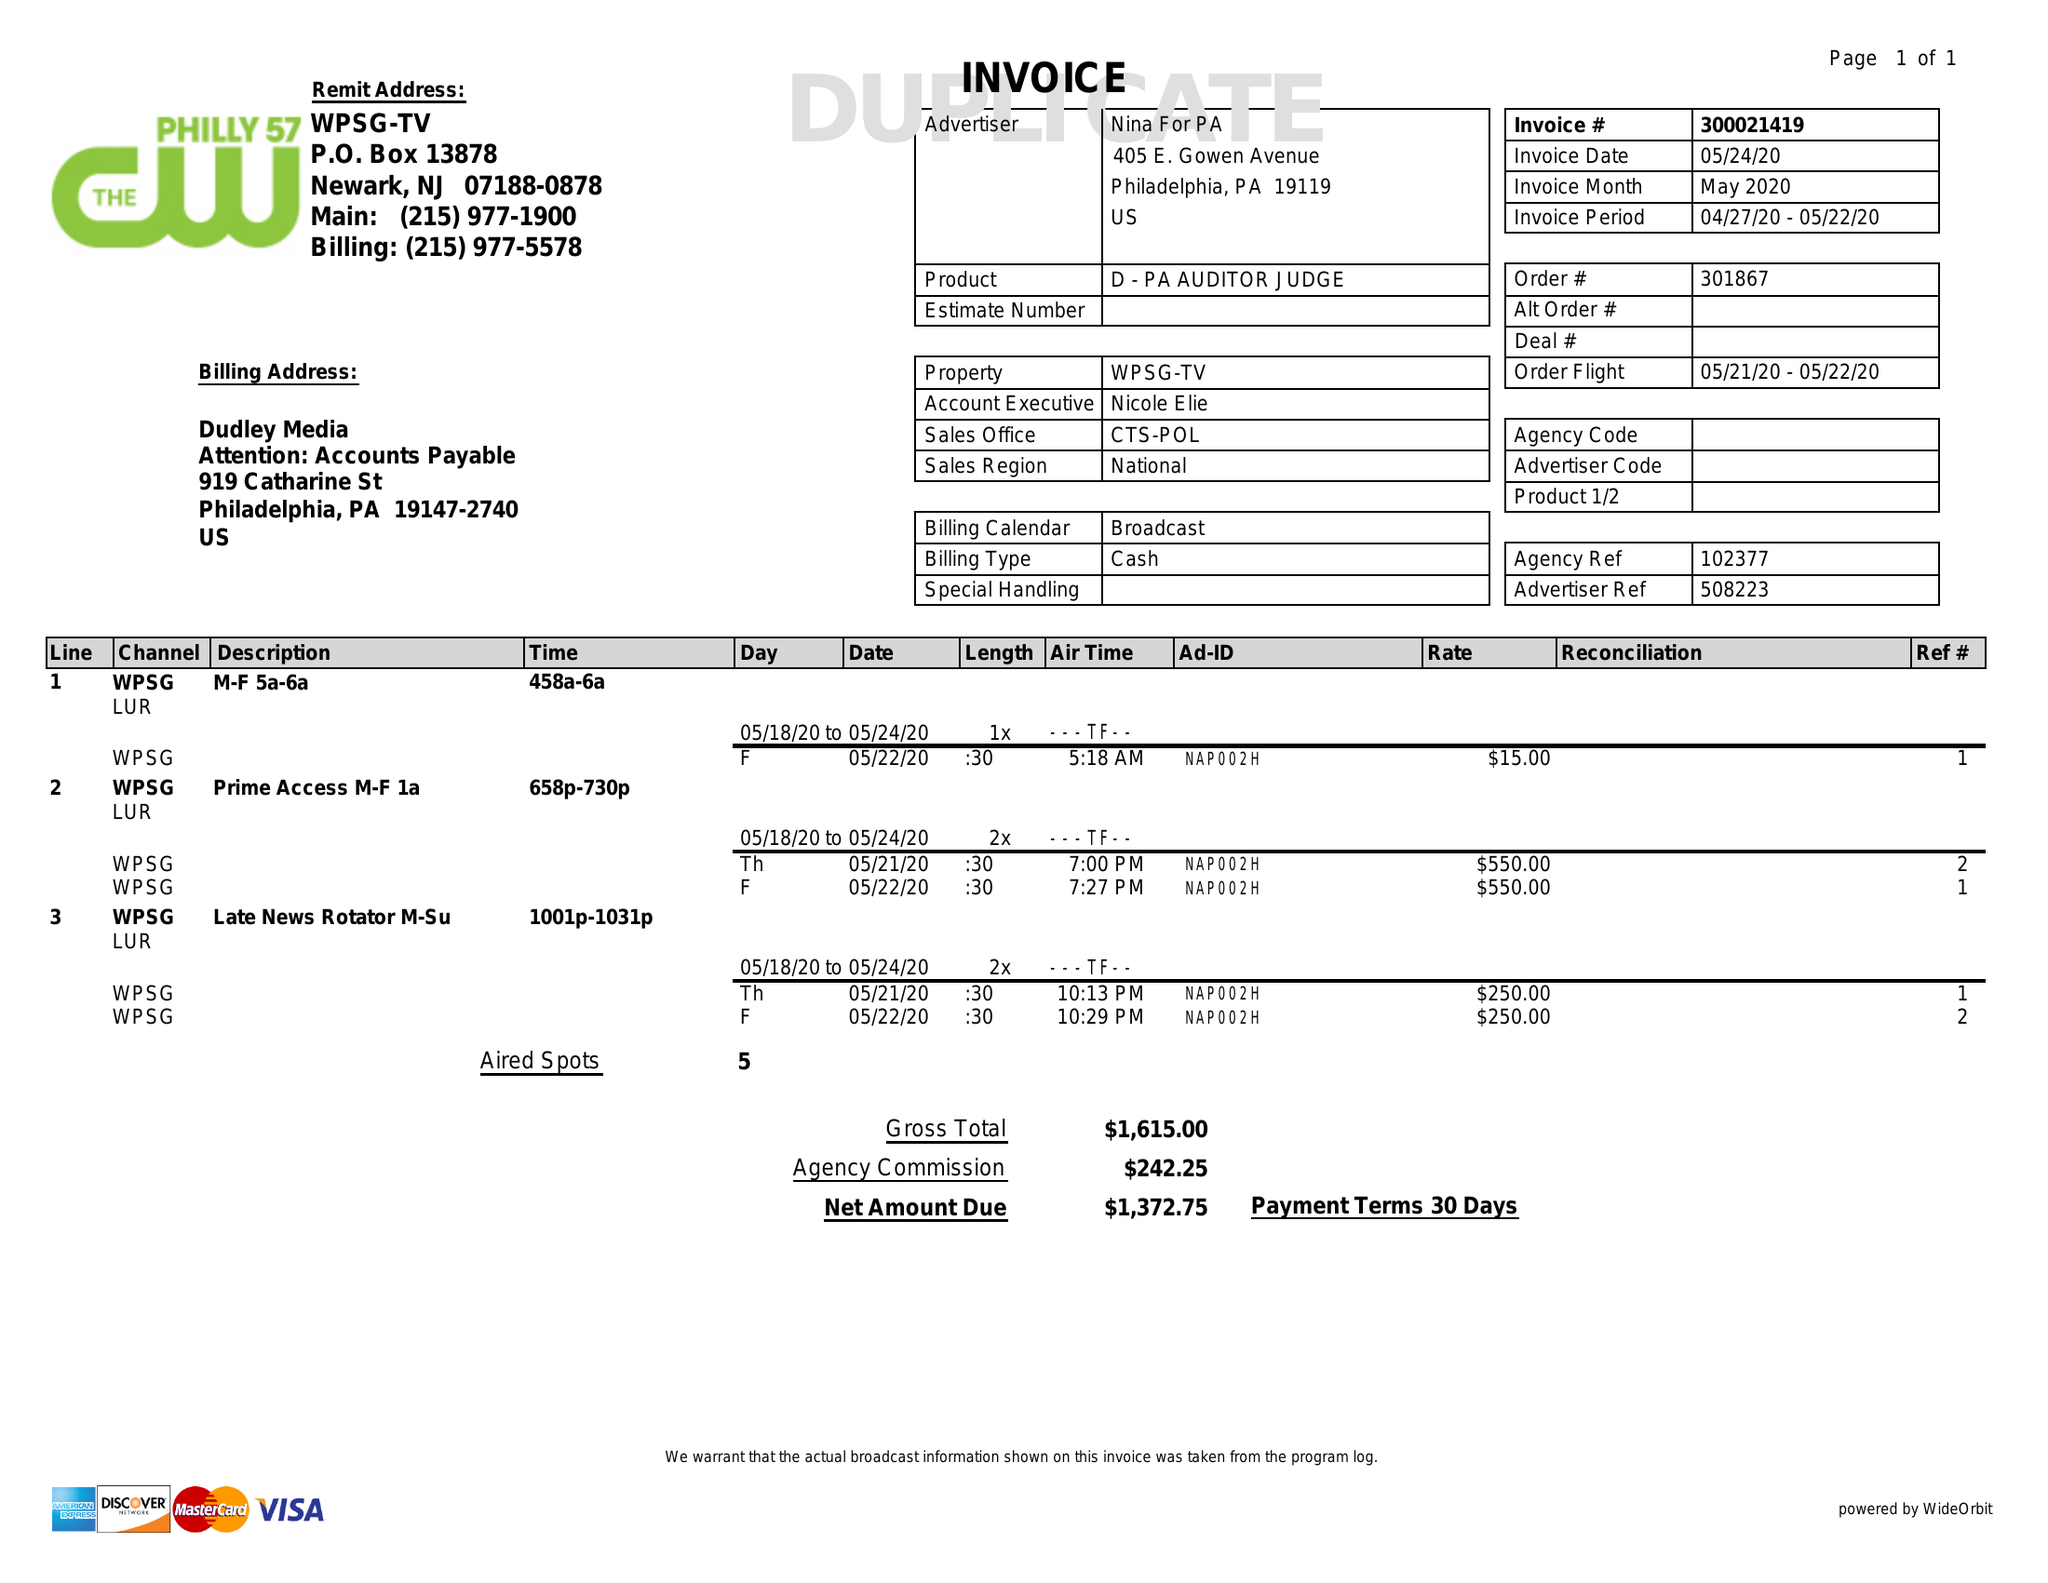What is the value for the flight_to?
Answer the question using a single word or phrase. 05/22/20 